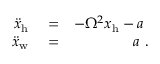<formula> <loc_0><loc_0><loc_500><loc_500>\begin{array} { r l r } { \ddot { x } _ { h } } & = } & { - \Omega ^ { 2 } x _ { h } - a } \\ { \ddot { x } _ { w } } & = } & { a . } \end{array}</formula> 